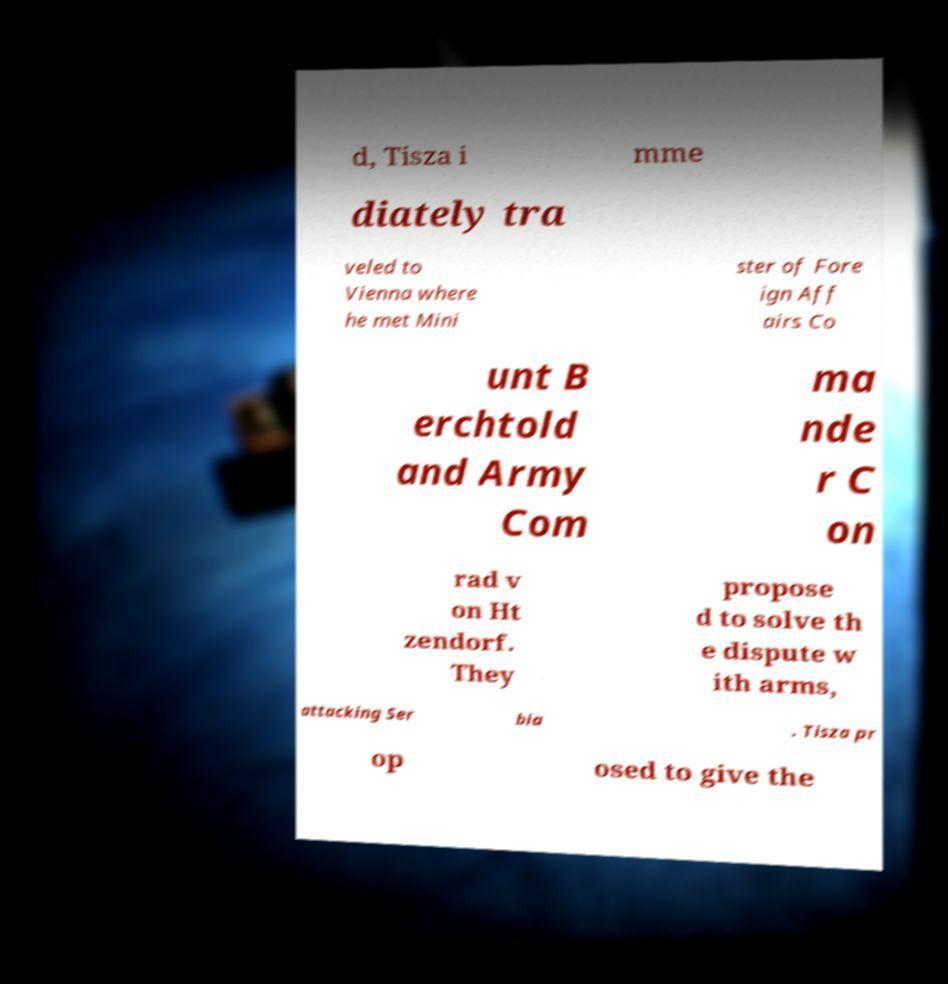Can you accurately transcribe the text from the provided image for me? d, Tisza i mme diately tra veled to Vienna where he met Mini ster of Fore ign Aff airs Co unt B erchtold and Army Com ma nde r C on rad v on Ht zendorf. They propose d to solve th e dispute w ith arms, attacking Ser bia . Tisza pr op osed to give the 